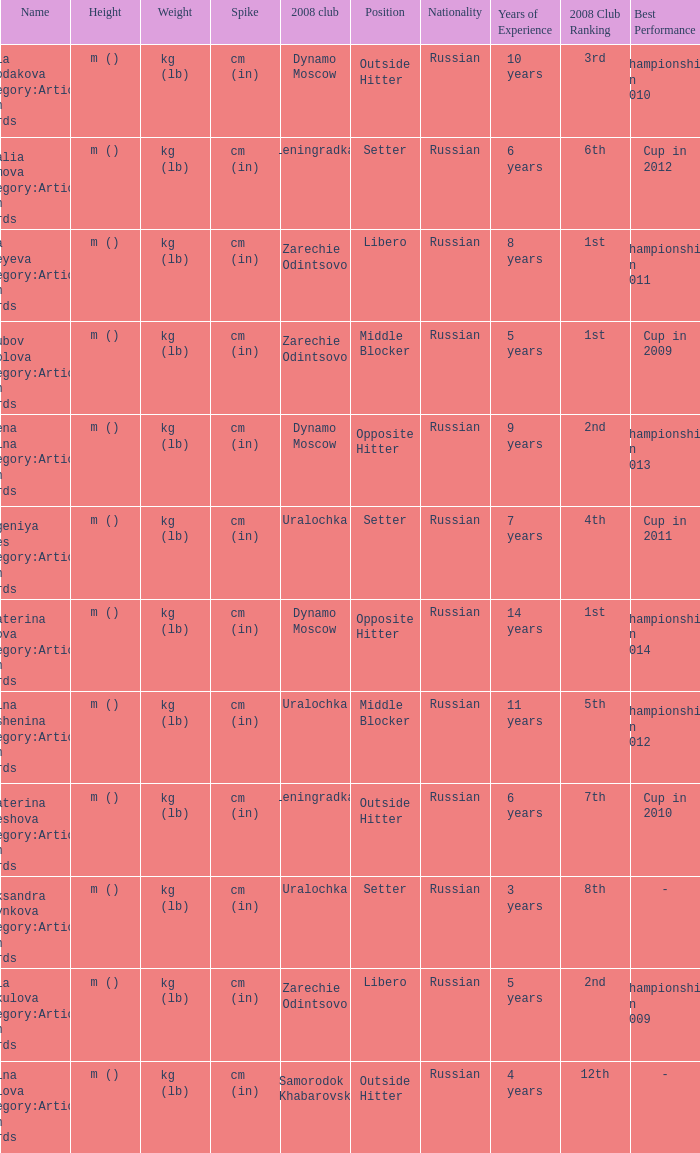What is the name of the 2008 club called zarechie odintsovo? Olga Fateyeva Category:Articles with hCards, Lioubov Sokolova Category:Articles with hCards, Yulia Merkulova Category:Articles with hCards. 